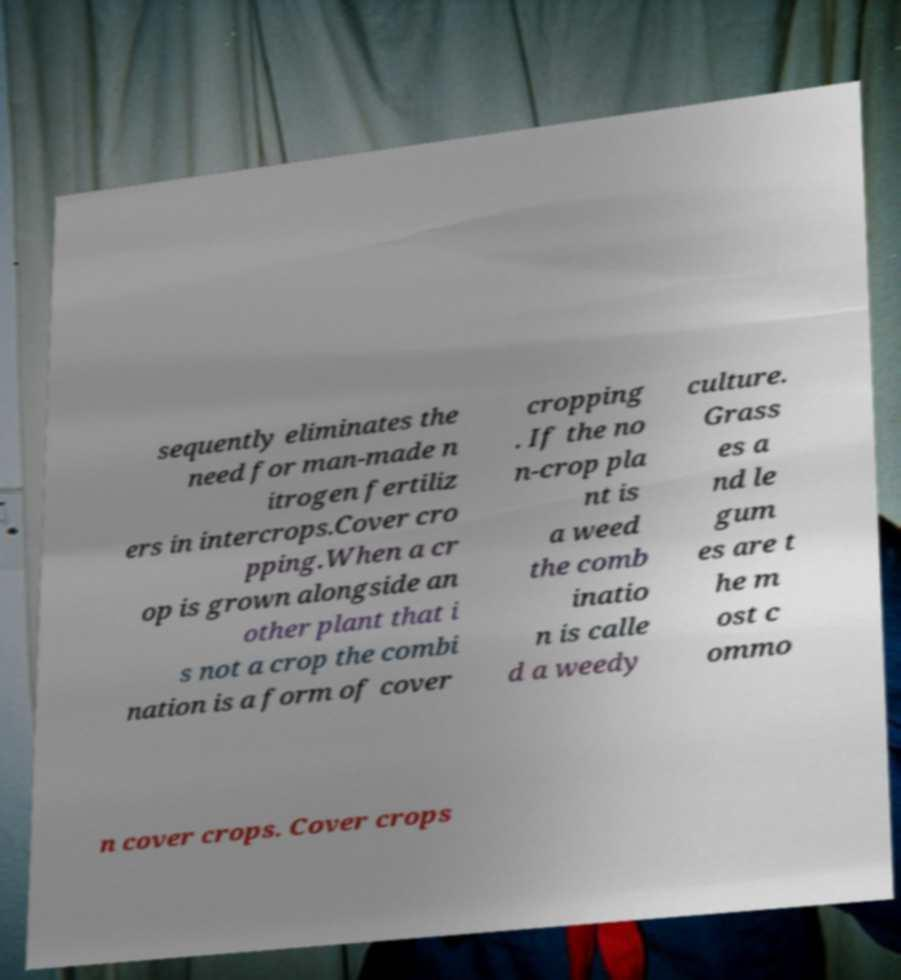What messages or text are displayed in this image? I need them in a readable, typed format. sequently eliminates the need for man-made n itrogen fertiliz ers in intercrops.Cover cro pping.When a cr op is grown alongside an other plant that i s not a crop the combi nation is a form of cover cropping . If the no n-crop pla nt is a weed the comb inatio n is calle d a weedy culture. Grass es a nd le gum es are t he m ost c ommo n cover crops. Cover crops 